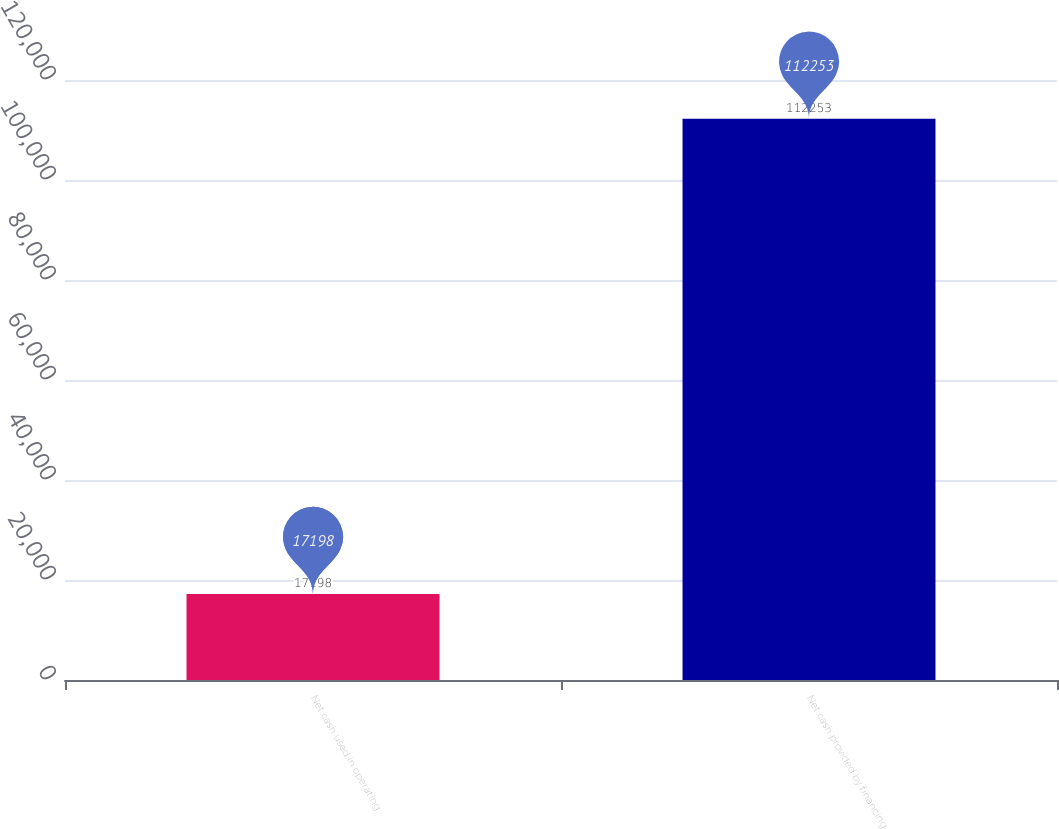Convert chart to OTSL. <chart><loc_0><loc_0><loc_500><loc_500><bar_chart><fcel>Net cash used in operating<fcel>Net cash provided by financing<nl><fcel>17198<fcel>112253<nl></chart> 